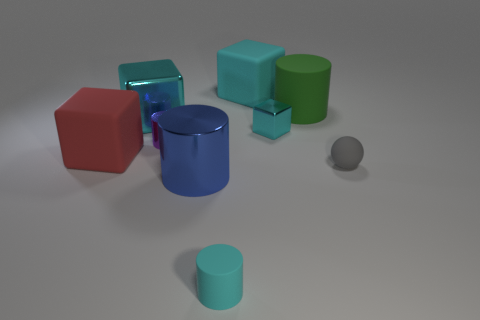There is another cylinder that is the same size as the green cylinder; what is it made of?
Offer a very short reply. Metal. What size is the cyan matte object in front of the sphere?
Give a very brief answer. Small. The ball has what size?
Ensure brevity in your answer.  Small. There is a red block; does it have the same size as the matte cube that is behind the big matte cylinder?
Provide a short and direct response. Yes. What is the color of the tiny cylinder in front of the small cylinder that is behind the tiny cyan cylinder?
Keep it short and to the point. Cyan. Are there the same number of big cyan objects in front of the tiny cyan shiny thing and gray matte balls in front of the tiny cyan cylinder?
Provide a succinct answer. Yes. Do the small thing that is in front of the blue cylinder and the tiny block have the same material?
Your answer should be very brief. No. What is the color of the cylinder that is on the right side of the big blue shiny thing and in front of the small gray thing?
Offer a terse response. Cyan. What number of big metallic cubes are left of the cyan metal thing to the left of the purple metallic cylinder?
Offer a terse response. 0. There is a cyan thing that is the same shape as the tiny purple shiny object; what material is it?
Offer a very short reply. Rubber. 